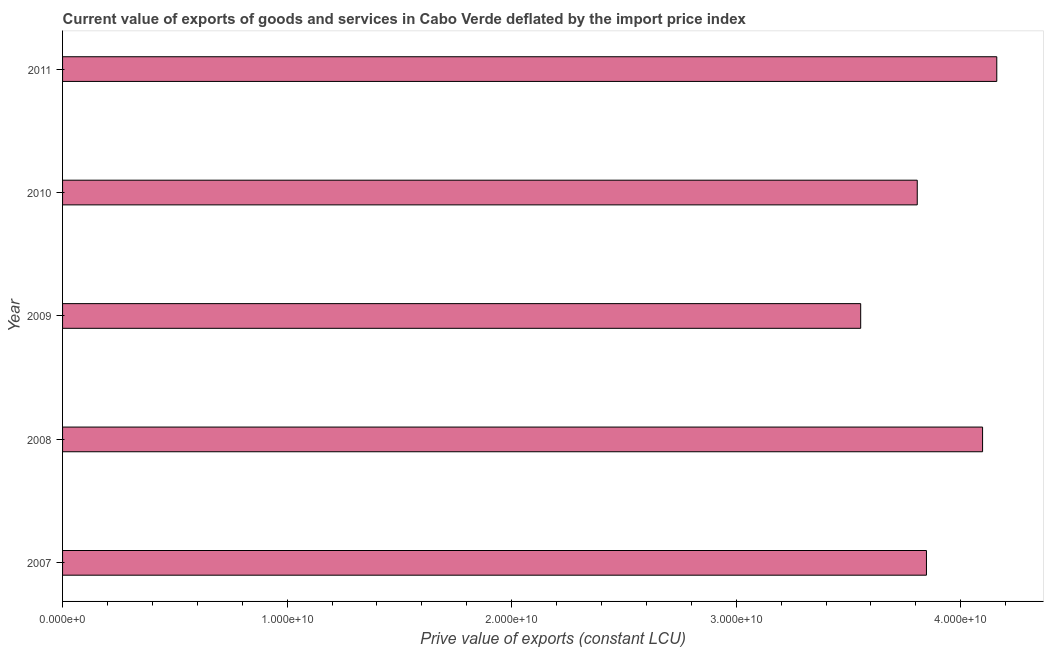Does the graph contain grids?
Give a very brief answer. No. What is the title of the graph?
Your answer should be compact. Current value of exports of goods and services in Cabo Verde deflated by the import price index. What is the label or title of the X-axis?
Give a very brief answer. Prive value of exports (constant LCU). What is the price value of exports in 2011?
Your answer should be very brief. 4.16e+1. Across all years, what is the maximum price value of exports?
Your response must be concise. 4.16e+1. Across all years, what is the minimum price value of exports?
Keep it short and to the point. 3.55e+1. In which year was the price value of exports maximum?
Your answer should be compact. 2011. What is the sum of the price value of exports?
Your answer should be very brief. 1.95e+11. What is the difference between the price value of exports in 2008 and 2011?
Provide a succinct answer. -6.33e+08. What is the average price value of exports per year?
Provide a succinct answer. 3.89e+1. What is the median price value of exports?
Your answer should be compact. 3.85e+1. What is the ratio of the price value of exports in 2008 to that in 2011?
Offer a terse response. 0.98. Is the price value of exports in 2008 less than that in 2011?
Offer a very short reply. Yes. What is the difference between the highest and the second highest price value of exports?
Offer a terse response. 6.33e+08. What is the difference between the highest and the lowest price value of exports?
Your answer should be compact. 6.06e+09. How many bars are there?
Your response must be concise. 5. Are all the bars in the graph horizontal?
Provide a succinct answer. Yes. Are the values on the major ticks of X-axis written in scientific E-notation?
Keep it short and to the point. Yes. What is the Prive value of exports (constant LCU) in 2007?
Provide a short and direct response. 3.85e+1. What is the Prive value of exports (constant LCU) in 2008?
Ensure brevity in your answer.  4.10e+1. What is the Prive value of exports (constant LCU) in 2009?
Provide a succinct answer. 3.55e+1. What is the Prive value of exports (constant LCU) in 2010?
Provide a succinct answer. 3.81e+1. What is the Prive value of exports (constant LCU) in 2011?
Provide a short and direct response. 4.16e+1. What is the difference between the Prive value of exports (constant LCU) in 2007 and 2008?
Offer a very short reply. -2.50e+09. What is the difference between the Prive value of exports (constant LCU) in 2007 and 2009?
Your answer should be compact. 2.93e+09. What is the difference between the Prive value of exports (constant LCU) in 2007 and 2010?
Make the answer very short. 4.10e+08. What is the difference between the Prive value of exports (constant LCU) in 2007 and 2011?
Keep it short and to the point. -3.13e+09. What is the difference between the Prive value of exports (constant LCU) in 2008 and 2009?
Offer a very short reply. 5.43e+09. What is the difference between the Prive value of exports (constant LCU) in 2008 and 2010?
Keep it short and to the point. 2.91e+09. What is the difference between the Prive value of exports (constant LCU) in 2008 and 2011?
Offer a very short reply. -6.33e+08. What is the difference between the Prive value of exports (constant LCU) in 2009 and 2010?
Offer a terse response. -2.52e+09. What is the difference between the Prive value of exports (constant LCU) in 2009 and 2011?
Make the answer very short. -6.06e+09. What is the difference between the Prive value of exports (constant LCU) in 2010 and 2011?
Provide a succinct answer. -3.54e+09. What is the ratio of the Prive value of exports (constant LCU) in 2007 to that in 2008?
Give a very brief answer. 0.94. What is the ratio of the Prive value of exports (constant LCU) in 2007 to that in 2009?
Offer a terse response. 1.08. What is the ratio of the Prive value of exports (constant LCU) in 2007 to that in 2011?
Ensure brevity in your answer.  0.93. What is the ratio of the Prive value of exports (constant LCU) in 2008 to that in 2009?
Your answer should be compact. 1.15. What is the ratio of the Prive value of exports (constant LCU) in 2008 to that in 2010?
Your response must be concise. 1.08. What is the ratio of the Prive value of exports (constant LCU) in 2009 to that in 2010?
Your answer should be compact. 0.93. What is the ratio of the Prive value of exports (constant LCU) in 2009 to that in 2011?
Make the answer very short. 0.85. What is the ratio of the Prive value of exports (constant LCU) in 2010 to that in 2011?
Offer a terse response. 0.92. 